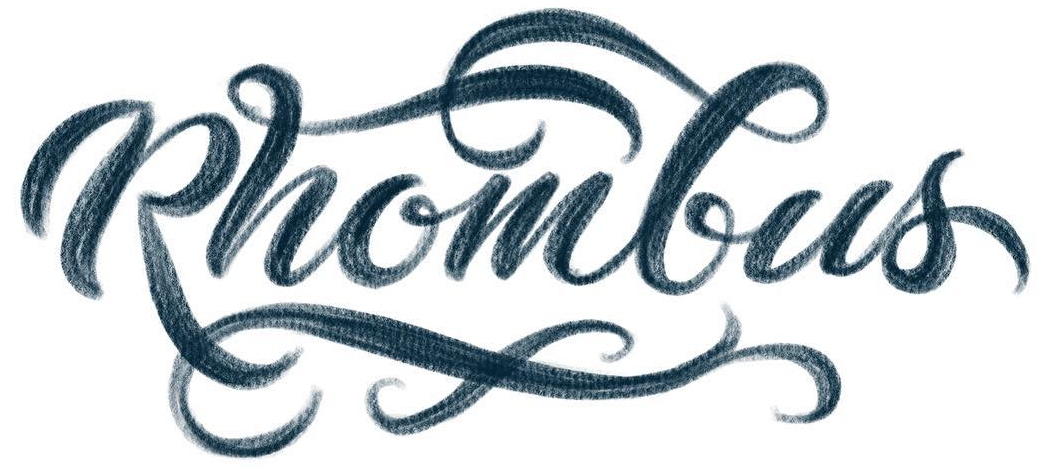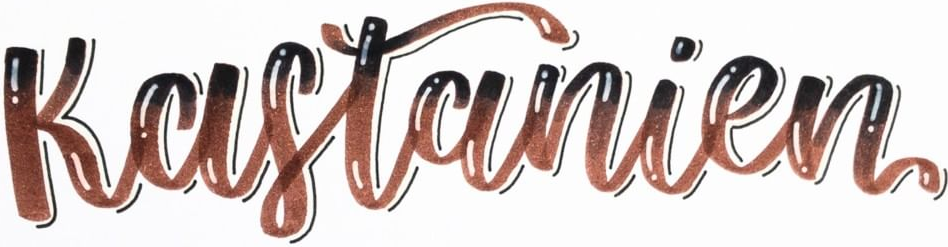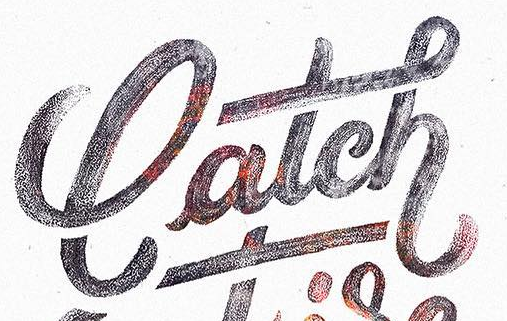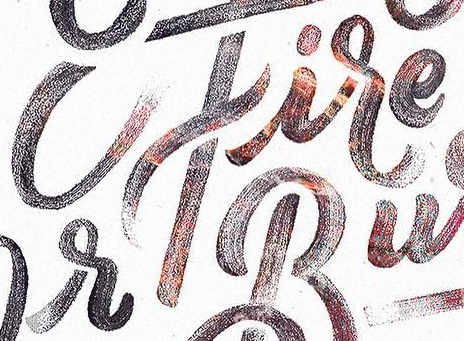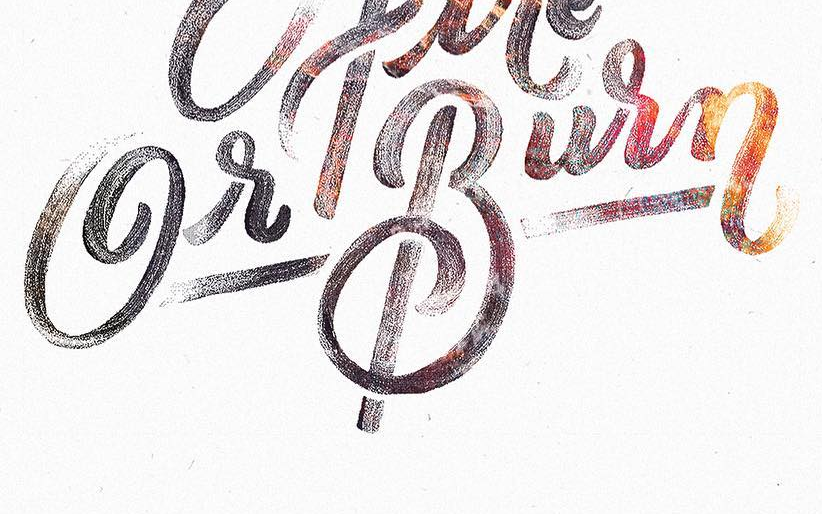Transcribe the words shown in these images in order, separated by a semicolon. Rhombus; Kastanien; latch; cfire; GrBurn 